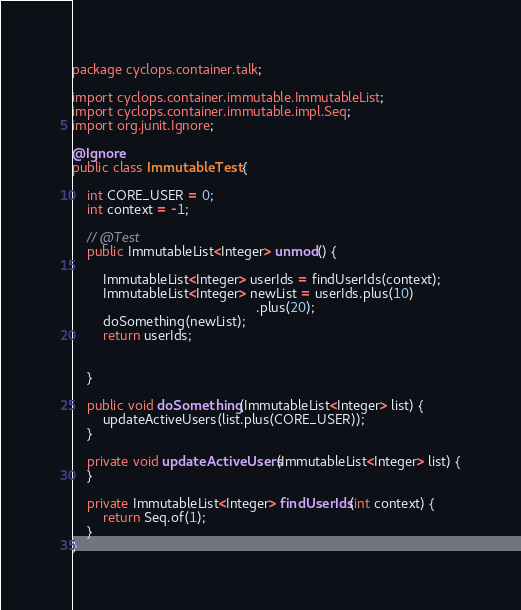<code> <loc_0><loc_0><loc_500><loc_500><_Java_>package cyclops.container.talk;

import cyclops.container.immutable.ImmutableList;
import cyclops.container.immutable.impl.Seq;
import org.junit.Ignore;

@Ignore
public class ImmutableTest {

    int CORE_USER = 0;
    int context = -1;

    // @Test
    public ImmutableList<Integer> unmod() {

        ImmutableList<Integer> userIds = findUserIds(context);
        ImmutableList<Integer> newList = userIds.plus(10)
                                                .plus(20);
        doSomething(newList);
        return userIds;


    }

    public void doSomething(ImmutableList<Integer> list) {
        updateActiveUsers(list.plus(CORE_USER));
    }

    private void updateActiveUsers(ImmutableList<Integer> list) {
    }

    private ImmutableList<Integer> findUserIds(int context) {
        return Seq.of(1);
    }
}
</code> 